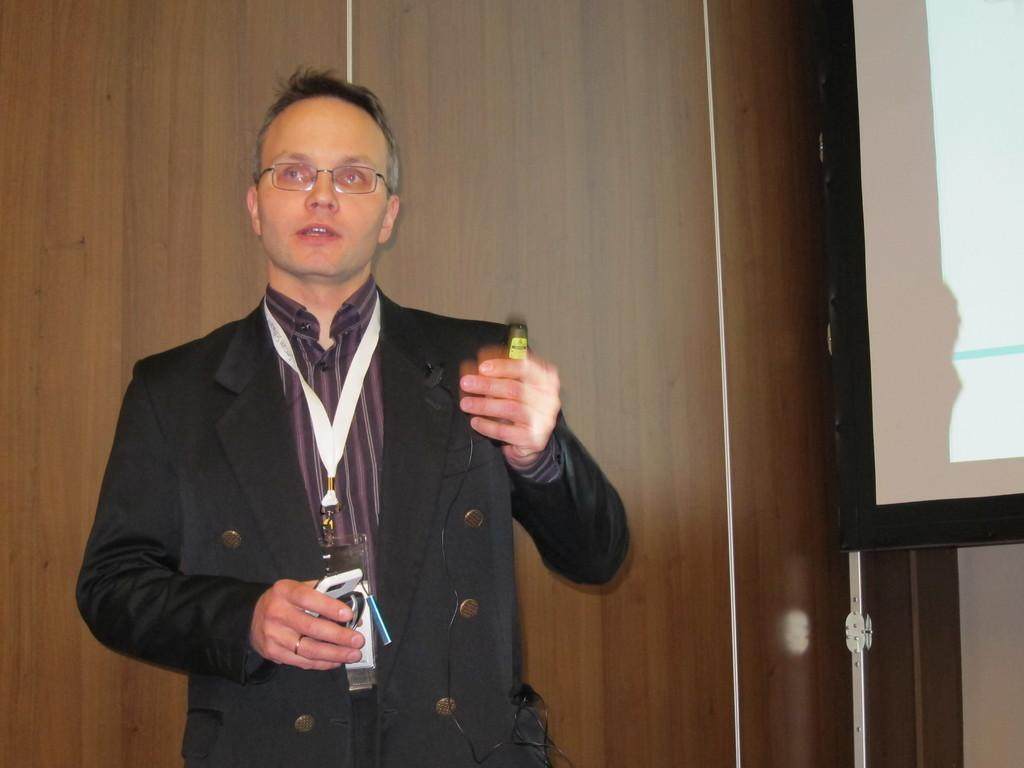What is the man in the image doing? The man is standing in the image and holding objects. Can you describe the objects the man is holding? The provided facts do not specify the objects the man is holding. What is on the right side of the image? There is a screen on the right side of the image. What type of wall is visible in the background of the image? There is a wooden wall in the background of the image. What type of temper can be seen in the man's expression in the image? The provided facts do not mention the man's expression or any indication of his temper. 